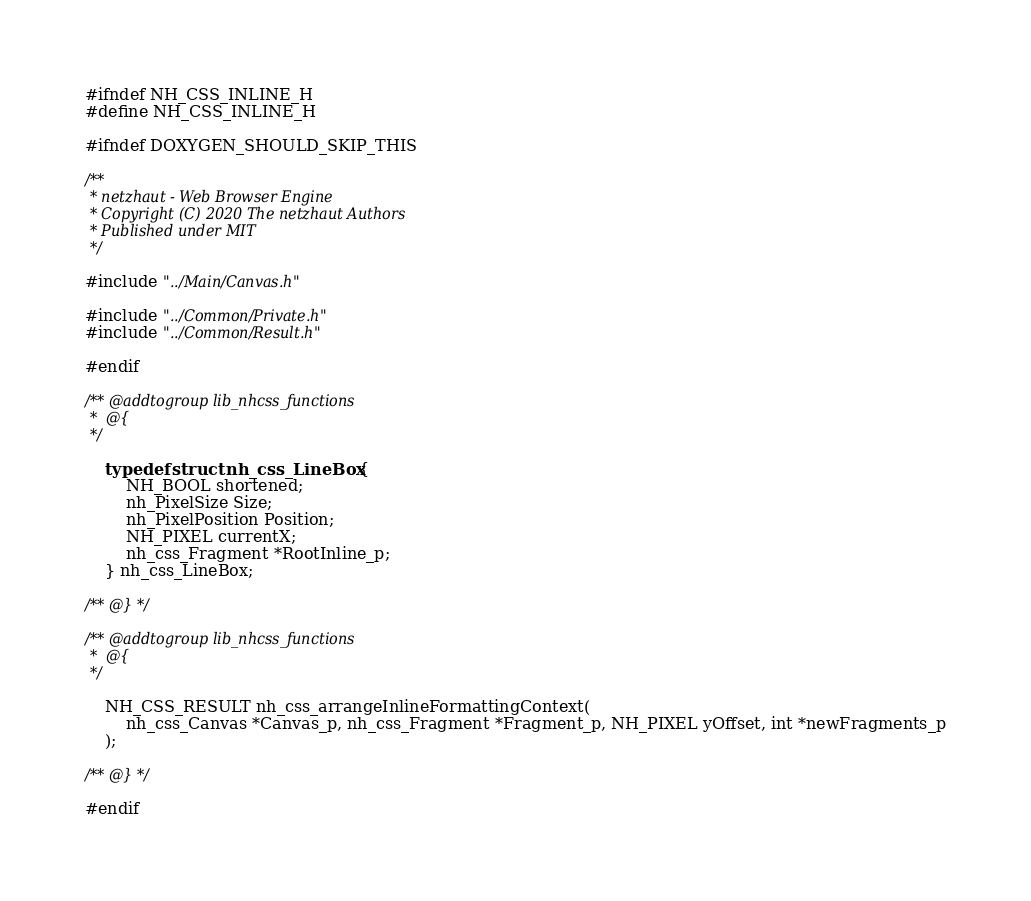<code> <loc_0><loc_0><loc_500><loc_500><_C_>#ifndef NH_CSS_INLINE_H
#define NH_CSS_INLINE_H

#ifndef DOXYGEN_SHOULD_SKIP_THIS

/**
 * netzhaut - Web Browser Engine
 * Copyright (C) 2020 The netzhaut Authors
 * Published under MIT
 */

#include "../Main/Canvas.h"

#include "../Common/Private.h"
#include "../Common/Result.h"

#endif

/** @addtogroup lib_nhcss_functions
 *  @{
 */

    typedef struct nh_css_LineBox {
        NH_BOOL shortened;
        nh_PixelSize Size;
        nh_PixelPosition Position;
        NH_PIXEL currentX;
        nh_css_Fragment *RootInline_p;
    } nh_css_LineBox;

/** @} */

/** @addtogroup lib_nhcss_functions
 *  @{
 */

    NH_CSS_RESULT nh_css_arrangeInlineFormattingContext(
        nh_css_Canvas *Canvas_p, nh_css_Fragment *Fragment_p, NH_PIXEL yOffset, int *newFragments_p
    );

/** @} */

#endif
</code> 